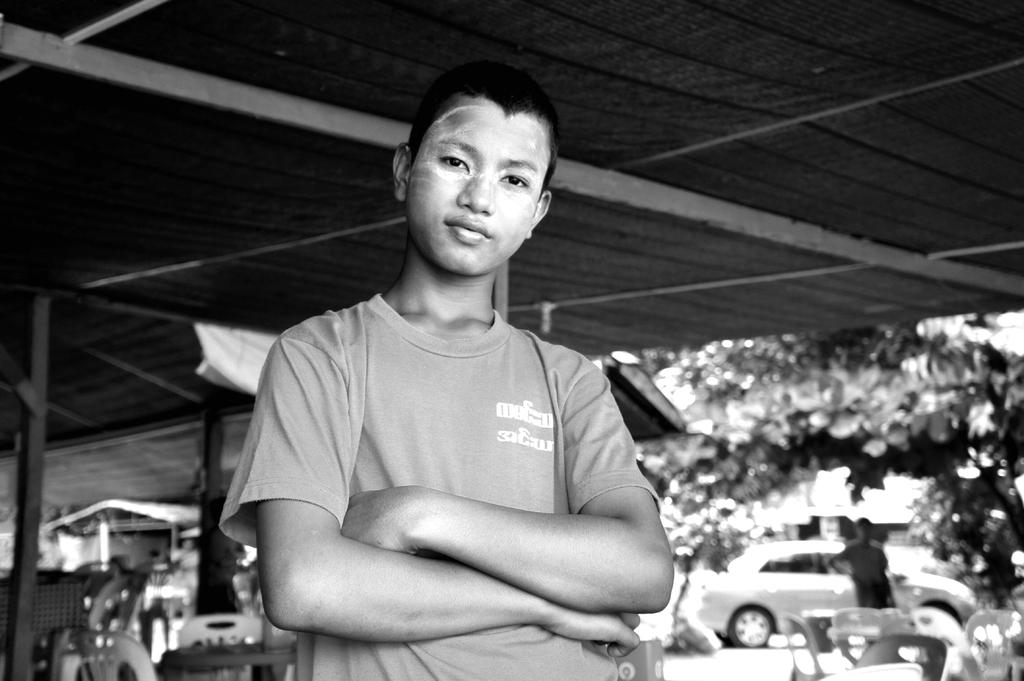What is the color scheme of the image? The image is black and white. What can be seen in the foreground of the image? There is a boy standing in the image. How would you describe the background of the image? The background is blurred, and there are open-sheds, trees, chairs, tables, a vehicle, and a person visible. How many eyes does the thrill have in the image? There is no thrill present in the image, and therefore no eyes can be counted. What type of key is used to unlock the vehicle in the background? There is no key visible in the image, and the vehicle's locking mechanism is not mentioned. 